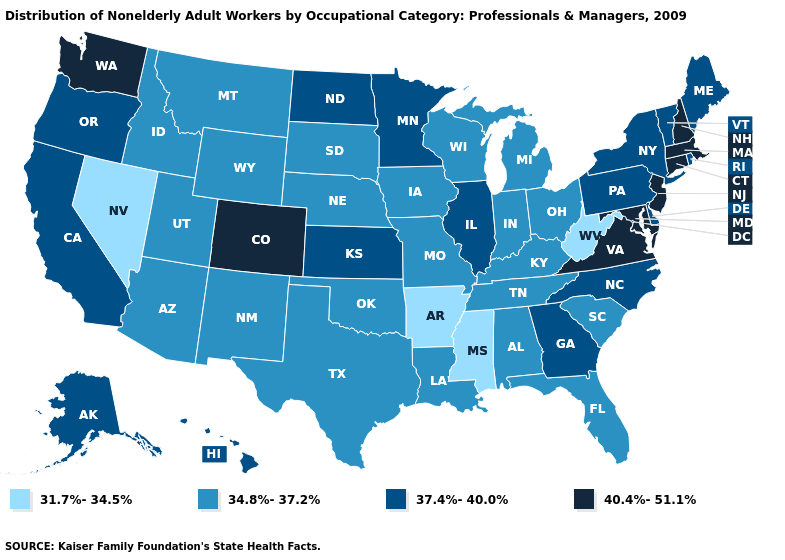Name the states that have a value in the range 34.8%-37.2%?
Answer briefly. Alabama, Arizona, Florida, Idaho, Indiana, Iowa, Kentucky, Louisiana, Michigan, Missouri, Montana, Nebraska, New Mexico, Ohio, Oklahoma, South Carolina, South Dakota, Tennessee, Texas, Utah, Wisconsin, Wyoming. What is the value of Massachusetts?
Short answer required. 40.4%-51.1%. How many symbols are there in the legend?
Quick response, please. 4. What is the value of Georgia?
Short answer required. 37.4%-40.0%. Among the states that border North Dakota , which have the highest value?
Answer briefly. Minnesota. What is the value of South Carolina?
Give a very brief answer. 34.8%-37.2%. Name the states that have a value in the range 37.4%-40.0%?
Be succinct. Alaska, California, Delaware, Georgia, Hawaii, Illinois, Kansas, Maine, Minnesota, New York, North Carolina, North Dakota, Oregon, Pennsylvania, Rhode Island, Vermont. What is the highest value in the MidWest ?
Keep it brief. 37.4%-40.0%. What is the lowest value in the South?
Give a very brief answer. 31.7%-34.5%. Name the states that have a value in the range 34.8%-37.2%?
Write a very short answer. Alabama, Arizona, Florida, Idaho, Indiana, Iowa, Kentucky, Louisiana, Michigan, Missouri, Montana, Nebraska, New Mexico, Ohio, Oklahoma, South Carolina, South Dakota, Tennessee, Texas, Utah, Wisconsin, Wyoming. Does Connecticut have the highest value in the USA?
Answer briefly. Yes. What is the highest value in the MidWest ?
Concise answer only. 37.4%-40.0%. How many symbols are there in the legend?
Give a very brief answer. 4. What is the value of Ohio?
Be succinct. 34.8%-37.2%. 